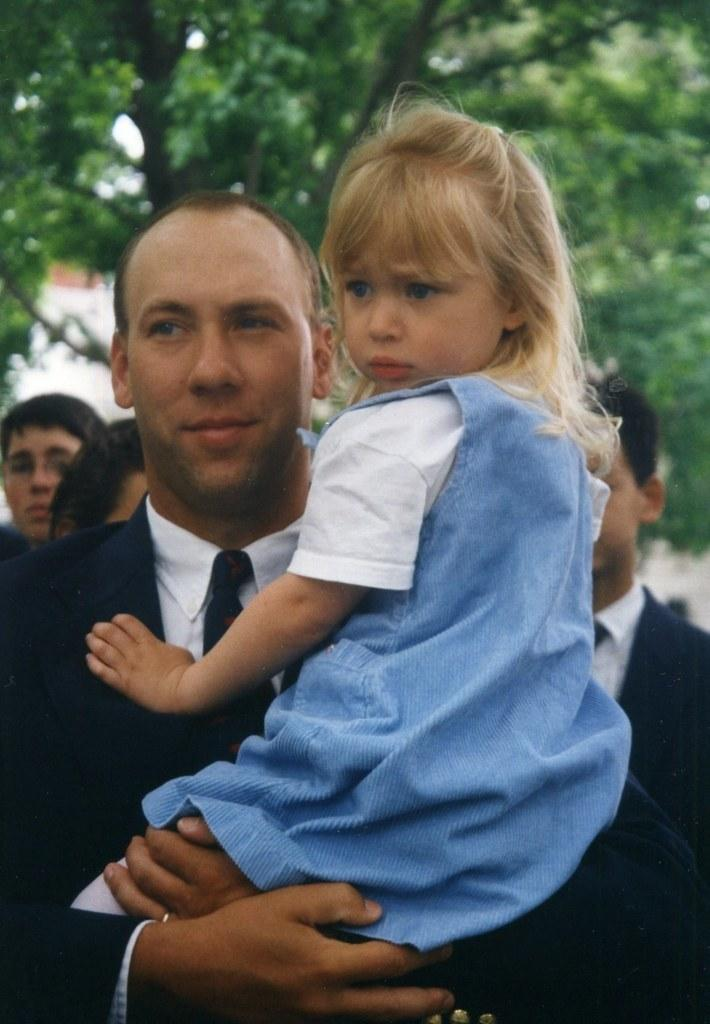What is the main action taking place in the image? There is a person holding a child in the image. Are there any other people present in the image? Yes, there are a few people behind the person holding the child. What can be seen in the background of the image? There are trees in the background of the image. What type of appliance is visible in the image? There is no appliance present in the image. Can you describe the detail of the child's clothing in the image? The provided facts do not include any information about the child's clothing, so it cannot be described. 